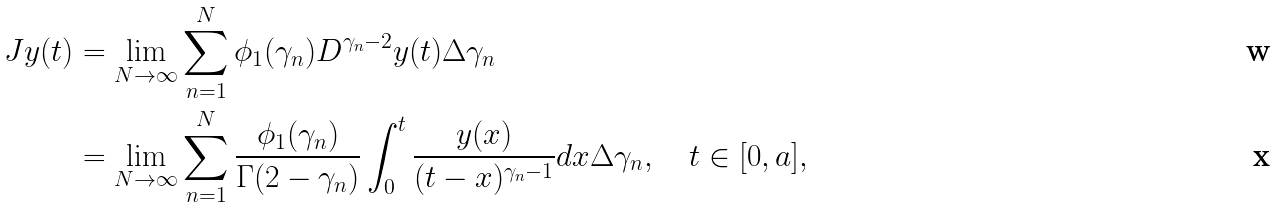<formula> <loc_0><loc_0><loc_500><loc_500>J y ( t ) & = \lim _ { N \rightarrow \infty } \sum _ { n = 1 } ^ { N } \phi _ { 1 } ( \gamma _ { n } ) D ^ { \gamma _ { n } - 2 } y ( t ) \Delta \gamma _ { n } \\ & = \lim _ { N \rightarrow \infty } \sum _ { n = 1 } ^ { N } \frac { \phi _ { 1 } ( \gamma _ { n } ) } { \Gamma ( 2 - \gamma _ { n } ) } \int _ { 0 } ^ { t } \frac { y ( x ) } { ( t - x ) ^ { \gamma _ { n } - 1 } } d x \Delta \gamma _ { n } , \quad t \in [ 0 , a ] ,</formula> 